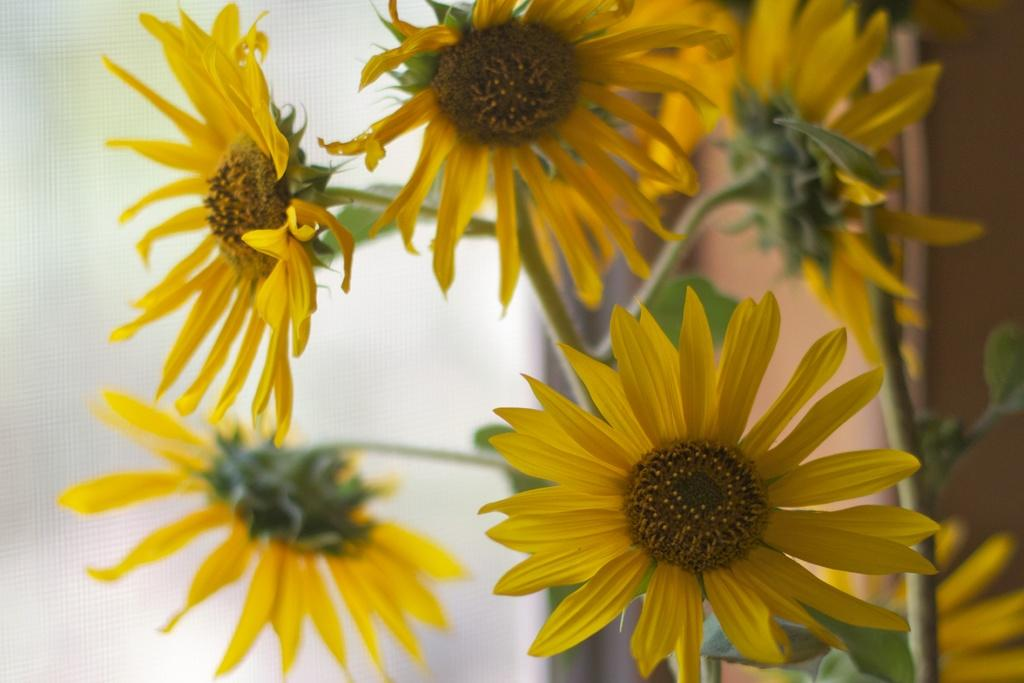What type of plants are in the image? There are sunflower plants in the image. Can you describe the background of the image? The background of the image is blurred. Where is the playground located in the image? There is no playground present in the image; it features sunflower plants and a blurred background. What type of nut can be seen growing on the sunflower plants in the image? Sunflower plants do not produce nuts; they produce seeds. 